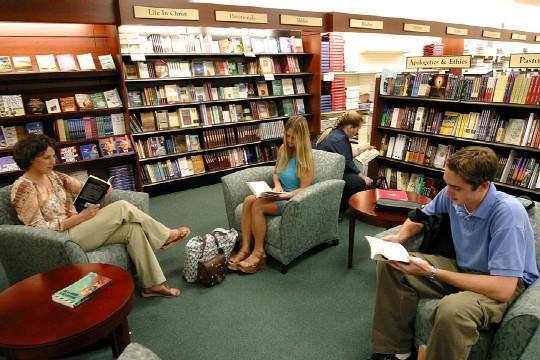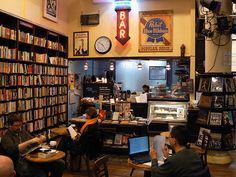The first image is the image on the left, the second image is the image on the right. Examine the images to the left and right. Is the description "The left image shows people standing on the left and right of a counter, with heads bent toward each other." accurate? Answer yes or no. No. 